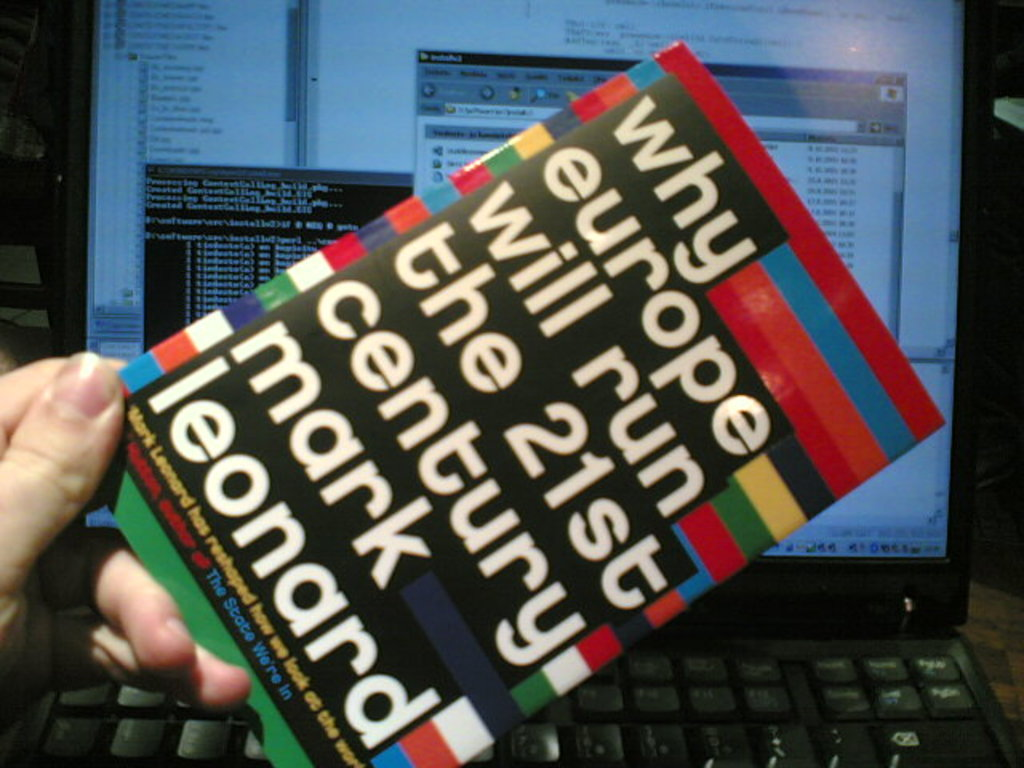What is the main argument of the book titled 'Why Europe Will Run the 21st Century' shown in the image? The book argues that, despite various challenges, Europe has a set of innovative political arrangements and is pioneering a form of post-modern statehood that can be a model for the future. 